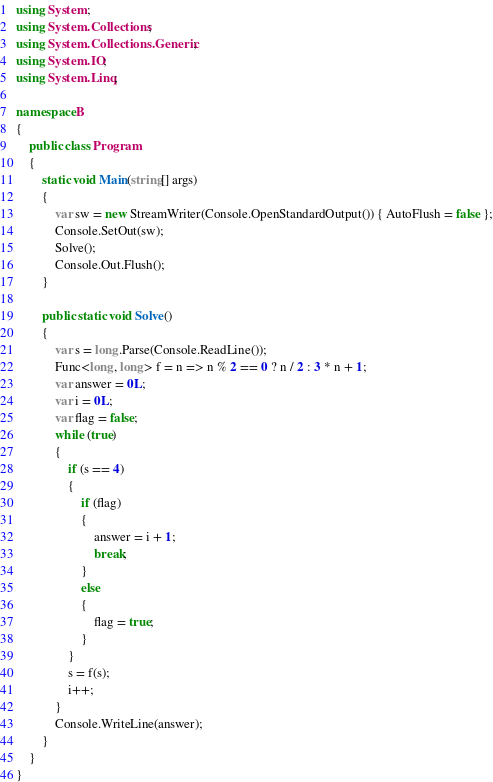<code> <loc_0><loc_0><loc_500><loc_500><_C#_>using System;
using System.Collections;
using System.Collections.Generic;
using System.IO;
using System.Linq;

namespace B
{
    public class Program
    {
        static void Main(string[] args)
        {
            var sw = new StreamWriter(Console.OpenStandardOutput()) { AutoFlush = false };
            Console.SetOut(sw);
            Solve();
            Console.Out.Flush();
        }

        public static void Solve()
        {
            var s = long.Parse(Console.ReadLine());
            Func<long, long> f = n => n % 2 == 0 ? n / 2 : 3 * n + 1;
            var answer = 0L;
            var i = 0L;
            var flag = false;
            while (true)
            {
                if (s == 4)
                {
                    if (flag)
                    {
                        answer = i + 1;
                        break;
                    }
                    else
                    {
                        flag = true;
                    }
                }
                s = f(s);
                i++;
            }
            Console.WriteLine(answer);
        }
    }
}
</code> 